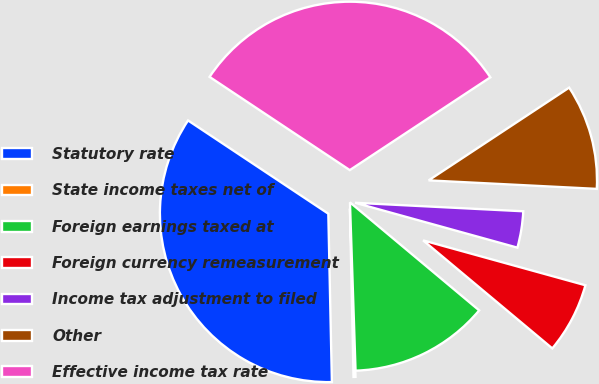<chart> <loc_0><loc_0><loc_500><loc_500><pie_chart><fcel>Statutory rate<fcel>State income taxes net of<fcel>Foreign earnings taxed at<fcel>Foreign currency remeasurement<fcel>Income tax adjustment to filed<fcel>Other<fcel>Effective income tax rate<nl><fcel>34.68%<fcel>0.19%<fcel>13.39%<fcel>6.79%<fcel>3.49%<fcel>10.09%<fcel>31.38%<nl></chart> 